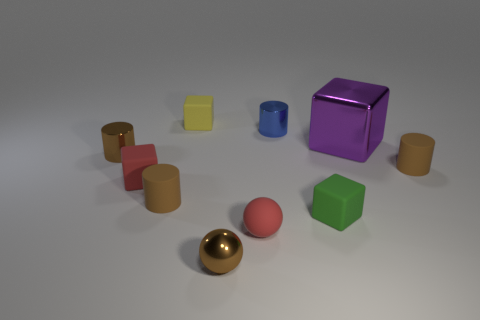Is there any other thing that has the same size as the purple shiny thing?
Provide a short and direct response. No. Is the number of big metal objects less than the number of tiny shiny objects?
Your answer should be very brief. Yes. There is a metallic cylinder left of the metallic sphere; is its color the same as the shiny ball?
Ensure brevity in your answer.  Yes. What is the material of the red thing in front of the tiny brown matte cylinder left of the small metal cylinder that is on the right side of the small red cube?
Give a very brief answer. Rubber. Is there another tiny metal sphere that has the same color as the small metallic sphere?
Keep it short and to the point. No. Are there fewer big things to the left of the big purple block than big cyan cubes?
Your answer should be compact. No. Is the size of the yellow object to the left of the metallic block the same as the small red block?
Your response must be concise. Yes. What number of shiny things are both in front of the matte ball and on the left side of the yellow thing?
Your answer should be very brief. 0. What size is the brown metal thing that is left of the small block behind the purple metal cube?
Offer a terse response. Small. Is the number of metallic balls in front of the small brown metal sphere less than the number of tiny objects on the right side of the purple block?
Make the answer very short. Yes. 